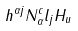<formula> <loc_0><loc_0><loc_500><loc_500>h ^ { \alpha j } N ^ { c } _ { \alpha } l _ { j } H _ { u }</formula> 